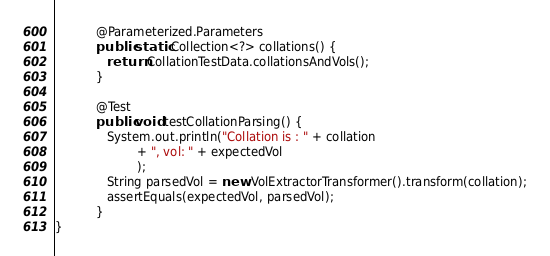<code> <loc_0><loc_0><loc_500><loc_500><_Java_>
		   @Parameterized.Parameters
		   public static Collection<?> collations() {
		      return CollationTestData.collationsAndVols();
		   }
		   
		   @Test
		   public void testCollationParsing() {
		      System.out.println("Collation is : " + collation 
		    		  + ", vol: " + expectedVol
		    		  );
		      String parsedVol = new VolExtractorTransformer().transform(collation);
		      assertEquals(expectedVol, parsedVol);
		   }
}</code> 